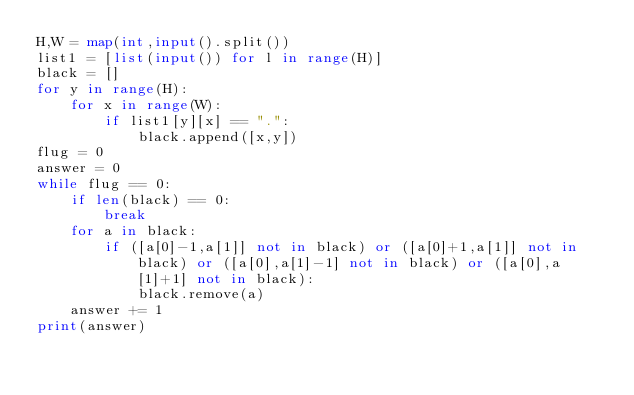<code> <loc_0><loc_0><loc_500><loc_500><_Python_>H,W = map(int,input().split())
list1 = [list(input()) for l in range(H)]
black = []
for y in range(H):
    for x in range(W):
        if list1[y][x] == ".":
            black.append([x,y])
flug = 0
answer = 0
while flug == 0:
    if len(black) == 0:
        break
    for a in black:
        if ([a[0]-1,a[1]] not in black) or ([a[0]+1,a[1]] not in black) or ([a[0],a[1]-1] not in black) or ([a[0],a[1]+1] not in black):
            black.remove(a)
    answer += 1
print(answer)</code> 